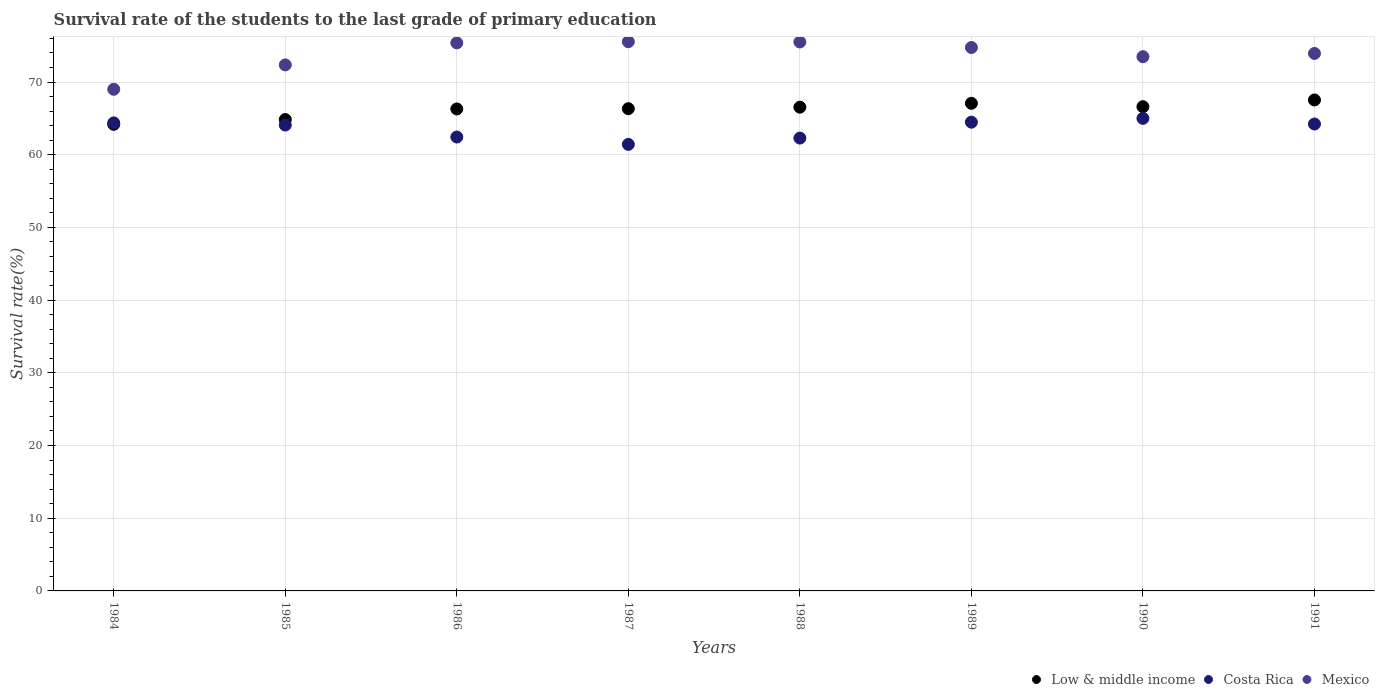How many different coloured dotlines are there?
Make the answer very short. 3. Is the number of dotlines equal to the number of legend labels?
Your answer should be compact. Yes. What is the survival rate of the students in Low & middle income in 1990?
Your answer should be compact. 66.61. Across all years, what is the maximum survival rate of the students in Costa Rica?
Give a very brief answer. 65. Across all years, what is the minimum survival rate of the students in Costa Rica?
Provide a short and direct response. 61.42. What is the total survival rate of the students in Mexico in the graph?
Offer a very short reply. 589.96. What is the difference between the survival rate of the students in Mexico in 1986 and that in 1987?
Make the answer very short. -0.16. What is the difference between the survival rate of the students in Mexico in 1988 and the survival rate of the students in Costa Rica in 1986?
Provide a short and direct response. 13.07. What is the average survival rate of the students in Mexico per year?
Your answer should be very brief. 73.74. In the year 1989, what is the difference between the survival rate of the students in Mexico and survival rate of the students in Costa Rica?
Ensure brevity in your answer.  10.27. What is the ratio of the survival rate of the students in Costa Rica in 1987 to that in 1989?
Provide a short and direct response. 0.95. Is the difference between the survival rate of the students in Mexico in 1988 and 1989 greater than the difference between the survival rate of the students in Costa Rica in 1988 and 1989?
Your answer should be compact. Yes. What is the difference between the highest and the second highest survival rate of the students in Low & middle income?
Your answer should be compact. 0.46. What is the difference between the highest and the lowest survival rate of the students in Mexico?
Ensure brevity in your answer.  6.54. In how many years, is the survival rate of the students in Low & middle income greater than the average survival rate of the students in Low & middle income taken over all years?
Provide a succinct answer. 6. Is it the case that in every year, the sum of the survival rate of the students in Costa Rica and survival rate of the students in Mexico  is greater than the survival rate of the students in Low & middle income?
Your response must be concise. Yes. Is the survival rate of the students in Costa Rica strictly less than the survival rate of the students in Mexico over the years?
Offer a terse response. Yes. Does the graph contain grids?
Provide a short and direct response. Yes. How many legend labels are there?
Give a very brief answer. 3. What is the title of the graph?
Offer a terse response. Survival rate of the students to the last grade of primary education. Does "Croatia" appear as one of the legend labels in the graph?
Give a very brief answer. No. What is the label or title of the Y-axis?
Keep it short and to the point. Survival rate(%). What is the Survival rate(%) of Low & middle income in 1984?
Provide a succinct answer. 64.18. What is the Survival rate(%) of Costa Rica in 1984?
Your response must be concise. 64.38. What is the Survival rate(%) of Mexico in 1984?
Give a very brief answer. 69. What is the Survival rate(%) in Low & middle income in 1985?
Give a very brief answer. 64.84. What is the Survival rate(%) in Costa Rica in 1985?
Offer a terse response. 64.08. What is the Survival rate(%) of Mexico in 1985?
Provide a succinct answer. 72.36. What is the Survival rate(%) in Low & middle income in 1986?
Your response must be concise. 66.3. What is the Survival rate(%) of Costa Rica in 1986?
Provide a short and direct response. 62.43. What is the Survival rate(%) of Mexico in 1986?
Make the answer very short. 75.39. What is the Survival rate(%) of Low & middle income in 1987?
Make the answer very short. 66.33. What is the Survival rate(%) of Costa Rica in 1987?
Offer a terse response. 61.42. What is the Survival rate(%) of Mexico in 1987?
Offer a very short reply. 75.55. What is the Survival rate(%) of Low & middle income in 1988?
Your response must be concise. 66.54. What is the Survival rate(%) in Costa Rica in 1988?
Keep it short and to the point. 62.29. What is the Survival rate(%) of Mexico in 1988?
Offer a very short reply. 75.51. What is the Survival rate(%) of Low & middle income in 1989?
Offer a very short reply. 67.07. What is the Survival rate(%) of Costa Rica in 1989?
Give a very brief answer. 64.48. What is the Survival rate(%) in Mexico in 1989?
Ensure brevity in your answer.  74.74. What is the Survival rate(%) of Low & middle income in 1990?
Your answer should be compact. 66.61. What is the Survival rate(%) of Costa Rica in 1990?
Your answer should be very brief. 65. What is the Survival rate(%) in Mexico in 1990?
Keep it short and to the point. 73.48. What is the Survival rate(%) in Low & middle income in 1991?
Your response must be concise. 67.53. What is the Survival rate(%) in Costa Rica in 1991?
Your answer should be compact. 64.22. What is the Survival rate(%) of Mexico in 1991?
Your answer should be compact. 73.93. Across all years, what is the maximum Survival rate(%) of Low & middle income?
Keep it short and to the point. 67.53. Across all years, what is the maximum Survival rate(%) of Costa Rica?
Make the answer very short. 65. Across all years, what is the maximum Survival rate(%) in Mexico?
Give a very brief answer. 75.55. Across all years, what is the minimum Survival rate(%) in Low & middle income?
Ensure brevity in your answer.  64.18. Across all years, what is the minimum Survival rate(%) of Costa Rica?
Provide a short and direct response. 61.42. Across all years, what is the minimum Survival rate(%) in Mexico?
Your answer should be compact. 69. What is the total Survival rate(%) of Low & middle income in the graph?
Provide a short and direct response. 529.4. What is the total Survival rate(%) in Costa Rica in the graph?
Offer a terse response. 508.3. What is the total Survival rate(%) of Mexico in the graph?
Provide a short and direct response. 589.96. What is the difference between the Survival rate(%) in Low & middle income in 1984 and that in 1985?
Offer a terse response. -0.66. What is the difference between the Survival rate(%) in Costa Rica in 1984 and that in 1985?
Provide a succinct answer. 0.3. What is the difference between the Survival rate(%) of Mexico in 1984 and that in 1985?
Give a very brief answer. -3.35. What is the difference between the Survival rate(%) in Low & middle income in 1984 and that in 1986?
Make the answer very short. -2.11. What is the difference between the Survival rate(%) in Costa Rica in 1984 and that in 1986?
Your response must be concise. 1.94. What is the difference between the Survival rate(%) of Mexico in 1984 and that in 1986?
Offer a terse response. -6.38. What is the difference between the Survival rate(%) of Low & middle income in 1984 and that in 1987?
Your answer should be compact. -2.15. What is the difference between the Survival rate(%) in Costa Rica in 1984 and that in 1987?
Make the answer very short. 2.96. What is the difference between the Survival rate(%) of Mexico in 1984 and that in 1987?
Your response must be concise. -6.54. What is the difference between the Survival rate(%) of Low & middle income in 1984 and that in 1988?
Ensure brevity in your answer.  -2.36. What is the difference between the Survival rate(%) in Costa Rica in 1984 and that in 1988?
Provide a succinct answer. 2.09. What is the difference between the Survival rate(%) of Mexico in 1984 and that in 1988?
Keep it short and to the point. -6.51. What is the difference between the Survival rate(%) in Low & middle income in 1984 and that in 1989?
Make the answer very short. -2.89. What is the difference between the Survival rate(%) in Costa Rica in 1984 and that in 1989?
Give a very brief answer. -0.1. What is the difference between the Survival rate(%) in Mexico in 1984 and that in 1989?
Give a very brief answer. -5.74. What is the difference between the Survival rate(%) in Low & middle income in 1984 and that in 1990?
Make the answer very short. -2.42. What is the difference between the Survival rate(%) of Costa Rica in 1984 and that in 1990?
Offer a very short reply. -0.62. What is the difference between the Survival rate(%) of Mexico in 1984 and that in 1990?
Ensure brevity in your answer.  -4.48. What is the difference between the Survival rate(%) of Low & middle income in 1984 and that in 1991?
Keep it short and to the point. -3.35. What is the difference between the Survival rate(%) of Costa Rica in 1984 and that in 1991?
Provide a succinct answer. 0.16. What is the difference between the Survival rate(%) in Mexico in 1984 and that in 1991?
Offer a very short reply. -4.93. What is the difference between the Survival rate(%) of Low & middle income in 1985 and that in 1986?
Your answer should be very brief. -1.45. What is the difference between the Survival rate(%) in Costa Rica in 1985 and that in 1986?
Provide a short and direct response. 1.64. What is the difference between the Survival rate(%) in Mexico in 1985 and that in 1986?
Ensure brevity in your answer.  -3.03. What is the difference between the Survival rate(%) in Low & middle income in 1985 and that in 1987?
Make the answer very short. -1.49. What is the difference between the Survival rate(%) in Costa Rica in 1985 and that in 1987?
Your response must be concise. 2.66. What is the difference between the Survival rate(%) in Mexico in 1985 and that in 1987?
Keep it short and to the point. -3.19. What is the difference between the Survival rate(%) of Low & middle income in 1985 and that in 1988?
Provide a short and direct response. -1.7. What is the difference between the Survival rate(%) in Costa Rica in 1985 and that in 1988?
Your answer should be very brief. 1.79. What is the difference between the Survival rate(%) in Mexico in 1985 and that in 1988?
Provide a short and direct response. -3.15. What is the difference between the Survival rate(%) in Low & middle income in 1985 and that in 1989?
Offer a terse response. -2.23. What is the difference between the Survival rate(%) in Costa Rica in 1985 and that in 1989?
Provide a short and direct response. -0.4. What is the difference between the Survival rate(%) in Mexico in 1985 and that in 1989?
Keep it short and to the point. -2.39. What is the difference between the Survival rate(%) of Low & middle income in 1985 and that in 1990?
Your response must be concise. -1.77. What is the difference between the Survival rate(%) of Costa Rica in 1985 and that in 1990?
Give a very brief answer. -0.92. What is the difference between the Survival rate(%) in Mexico in 1985 and that in 1990?
Make the answer very short. -1.13. What is the difference between the Survival rate(%) in Low & middle income in 1985 and that in 1991?
Offer a very short reply. -2.69. What is the difference between the Survival rate(%) of Costa Rica in 1985 and that in 1991?
Ensure brevity in your answer.  -0.14. What is the difference between the Survival rate(%) of Mexico in 1985 and that in 1991?
Give a very brief answer. -1.57. What is the difference between the Survival rate(%) in Low & middle income in 1986 and that in 1987?
Make the answer very short. -0.04. What is the difference between the Survival rate(%) in Costa Rica in 1986 and that in 1987?
Your answer should be very brief. 1.01. What is the difference between the Survival rate(%) of Mexico in 1986 and that in 1987?
Provide a succinct answer. -0.16. What is the difference between the Survival rate(%) in Low & middle income in 1986 and that in 1988?
Offer a very short reply. -0.24. What is the difference between the Survival rate(%) in Costa Rica in 1986 and that in 1988?
Offer a very short reply. 0.14. What is the difference between the Survival rate(%) of Mexico in 1986 and that in 1988?
Provide a short and direct response. -0.12. What is the difference between the Survival rate(%) of Low & middle income in 1986 and that in 1989?
Provide a short and direct response. -0.77. What is the difference between the Survival rate(%) of Costa Rica in 1986 and that in 1989?
Offer a very short reply. -2.04. What is the difference between the Survival rate(%) in Mexico in 1986 and that in 1989?
Provide a succinct answer. 0.64. What is the difference between the Survival rate(%) in Low & middle income in 1986 and that in 1990?
Offer a very short reply. -0.31. What is the difference between the Survival rate(%) of Costa Rica in 1986 and that in 1990?
Provide a succinct answer. -2.57. What is the difference between the Survival rate(%) in Mexico in 1986 and that in 1990?
Make the answer very short. 1.9. What is the difference between the Survival rate(%) of Low & middle income in 1986 and that in 1991?
Ensure brevity in your answer.  -1.24. What is the difference between the Survival rate(%) in Costa Rica in 1986 and that in 1991?
Ensure brevity in your answer.  -1.79. What is the difference between the Survival rate(%) of Mexico in 1986 and that in 1991?
Your answer should be compact. 1.45. What is the difference between the Survival rate(%) of Low & middle income in 1987 and that in 1988?
Ensure brevity in your answer.  -0.21. What is the difference between the Survival rate(%) in Costa Rica in 1987 and that in 1988?
Offer a terse response. -0.87. What is the difference between the Survival rate(%) of Mexico in 1987 and that in 1988?
Give a very brief answer. 0.04. What is the difference between the Survival rate(%) of Low & middle income in 1987 and that in 1989?
Your answer should be very brief. -0.74. What is the difference between the Survival rate(%) in Costa Rica in 1987 and that in 1989?
Provide a short and direct response. -3.05. What is the difference between the Survival rate(%) of Mexico in 1987 and that in 1989?
Ensure brevity in your answer.  0.8. What is the difference between the Survival rate(%) in Low & middle income in 1987 and that in 1990?
Provide a short and direct response. -0.27. What is the difference between the Survival rate(%) of Costa Rica in 1987 and that in 1990?
Keep it short and to the point. -3.58. What is the difference between the Survival rate(%) in Mexico in 1987 and that in 1990?
Your response must be concise. 2.06. What is the difference between the Survival rate(%) of Low & middle income in 1987 and that in 1991?
Offer a very short reply. -1.2. What is the difference between the Survival rate(%) in Costa Rica in 1987 and that in 1991?
Provide a succinct answer. -2.8. What is the difference between the Survival rate(%) of Mexico in 1987 and that in 1991?
Your answer should be very brief. 1.61. What is the difference between the Survival rate(%) in Low & middle income in 1988 and that in 1989?
Offer a terse response. -0.53. What is the difference between the Survival rate(%) in Costa Rica in 1988 and that in 1989?
Your response must be concise. -2.19. What is the difference between the Survival rate(%) in Mexico in 1988 and that in 1989?
Your response must be concise. 0.76. What is the difference between the Survival rate(%) of Low & middle income in 1988 and that in 1990?
Offer a terse response. -0.07. What is the difference between the Survival rate(%) of Costa Rica in 1988 and that in 1990?
Your response must be concise. -2.71. What is the difference between the Survival rate(%) of Mexico in 1988 and that in 1990?
Keep it short and to the point. 2.03. What is the difference between the Survival rate(%) of Low & middle income in 1988 and that in 1991?
Provide a short and direct response. -1. What is the difference between the Survival rate(%) of Costa Rica in 1988 and that in 1991?
Your response must be concise. -1.93. What is the difference between the Survival rate(%) in Mexico in 1988 and that in 1991?
Your answer should be very brief. 1.58. What is the difference between the Survival rate(%) in Low & middle income in 1989 and that in 1990?
Give a very brief answer. 0.46. What is the difference between the Survival rate(%) of Costa Rica in 1989 and that in 1990?
Keep it short and to the point. -0.53. What is the difference between the Survival rate(%) in Mexico in 1989 and that in 1990?
Offer a terse response. 1.26. What is the difference between the Survival rate(%) of Low & middle income in 1989 and that in 1991?
Your answer should be compact. -0.46. What is the difference between the Survival rate(%) of Costa Rica in 1989 and that in 1991?
Your response must be concise. 0.25. What is the difference between the Survival rate(%) in Mexico in 1989 and that in 1991?
Offer a terse response. 0.81. What is the difference between the Survival rate(%) in Low & middle income in 1990 and that in 1991?
Provide a succinct answer. -0.93. What is the difference between the Survival rate(%) in Costa Rica in 1990 and that in 1991?
Offer a very short reply. 0.78. What is the difference between the Survival rate(%) of Mexico in 1990 and that in 1991?
Your answer should be compact. -0.45. What is the difference between the Survival rate(%) in Low & middle income in 1984 and the Survival rate(%) in Costa Rica in 1985?
Ensure brevity in your answer.  0.1. What is the difference between the Survival rate(%) in Low & middle income in 1984 and the Survival rate(%) in Mexico in 1985?
Your answer should be very brief. -8.17. What is the difference between the Survival rate(%) in Costa Rica in 1984 and the Survival rate(%) in Mexico in 1985?
Ensure brevity in your answer.  -7.98. What is the difference between the Survival rate(%) in Low & middle income in 1984 and the Survival rate(%) in Costa Rica in 1986?
Ensure brevity in your answer.  1.75. What is the difference between the Survival rate(%) in Low & middle income in 1984 and the Survival rate(%) in Mexico in 1986?
Offer a terse response. -11.2. What is the difference between the Survival rate(%) of Costa Rica in 1984 and the Survival rate(%) of Mexico in 1986?
Provide a short and direct response. -11.01. What is the difference between the Survival rate(%) in Low & middle income in 1984 and the Survival rate(%) in Costa Rica in 1987?
Offer a terse response. 2.76. What is the difference between the Survival rate(%) in Low & middle income in 1984 and the Survival rate(%) in Mexico in 1987?
Offer a terse response. -11.36. What is the difference between the Survival rate(%) in Costa Rica in 1984 and the Survival rate(%) in Mexico in 1987?
Make the answer very short. -11.17. What is the difference between the Survival rate(%) of Low & middle income in 1984 and the Survival rate(%) of Costa Rica in 1988?
Provide a short and direct response. 1.89. What is the difference between the Survival rate(%) in Low & middle income in 1984 and the Survival rate(%) in Mexico in 1988?
Offer a terse response. -11.33. What is the difference between the Survival rate(%) of Costa Rica in 1984 and the Survival rate(%) of Mexico in 1988?
Offer a very short reply. -11.13. What is the difference between the Survival rate(%) in Low & middle income in 1984 and the Survival rate(%) in Costa Rica in 1989?
Provide a succinct answer. -0.29. What is the difference between the Survival rate(%) in Low & middle income in 1984 and the Survival rate(%) in Mexico in 1989?
Provide a short and direct response. -10.56. What is the difference between the Survival rate(%) of Costa Rica in 1984 and the Survival rate(%) of Mexico in 1989?
Give a very brief answer. -10.37. What is the difference between the Survival rate(%) of Low & middle income in 1984 and the Survival rate(%) of Costa Rica in 1990?
Make the answer very short. -0.82. What is the difference between the Survival rate(%) in Low & middle income in 1984 and the Survival rate(%) in Mexico in 1990?
Make the answer very short. -9.3. What is the difference between the Survival rate(%) in Costa Rica in 1984 and the Survival rate(%) in Mexico in 1990?
Ensure brevity in your answer.  -9.11. What is the difference between the Survival rate(%) of Low & middle income in 1984 and the Survival rate(%) of Costa Rica in 1991?
Offer a terse response. -0.04. What is the difference between the Survival rate(%) of Low & middle income in 1984 and the Survival rate(%) of Mexico in 1991?
Provide a succinct answer. -9.75. What is the difference between the Survival rate(%) of Costa Rica in 1984 and the Survival rate(%) of Mexico in 1991?
Offer a terse response. -9.55. What is the difference between the Survival rate(%) of Low & middle income in 1985 and the Survival rate(%) of Costa Rica in 1986?
Offer a terse response. 2.41. What is the difference between the Survival rate(%) of Low & middle income in 1985 and the Survival rate(%) of Mexico in 1986?
Offer a very short reply. -10.54. What is the difference between the Survival rate(%) in Costa Rica in 1985 and the Survival rate(%) in Mexico in 1986?
Give a very brief answer. -11.31. What is the difference between the Survival rate(%) in Low & middle income in 1985 and the Survival rate(%) in Costa Rica in 1987?
Make the answer very short. 3.42. What is the difference between the Survival rate(%) in Low & middle income in 1985 and the Survival rate(%) in Mexico in 1987?
Your answer should be compact. -10.7. What is the difference between the Survival rate(%) of Costa Rica in 1985 and the Survival rate(%) of Mexico in 1987?
Offer a very short reply. -11.47. What is the difference between the Survival rate(%) in Low & middle income in 1985 and the Survival rate(%) in Costa Rica in 1988?
Offer a terse response. 2.55. What is the difference between the Survival rate(%) in Low & middle income in 1985 and the Survival rate(%) in Mexico in 1988?
Your response must be concise. -10.67. What is the difference between the Survival rate(%) of Costa Rica in 1985 and the Survival rate(%) of Mexico in 1988?
Your answer should be compact. -11.43. What is the difference between the Survival rate(%) of Low & middle income in 1985 and the Survival rate(%) of Costa Rica in 1989?
Provide a succinct answer. 0.36. What is the difference between the Survival rate(%) in Low & middle income in 1985 and the Survival rate(%) in Mexico in 1989?
Your answer should be compact. -9.9. What is the difference between the Survival rate(%) of Costa Rica in 1985 and the Survival rate(%) of Mexico in 1989?
Your response must be concise. -10.67. What is the difference between the Survival rate(%) of Low & middle income in 1985 and the Survival rate(%) of Costa Rica in 1990?
Your answer should be very brief. -0.16. What is the difference between the Survival rate(%) of Low & middle income in 1985 and the Survival rate(%) of Mexico in 1990?
Provide a succinct answer. -8.64. What is the difference between the Survival rate(%) in Costa Rica in 1985 and the Survival rate(%) in Mexico in 1990?
Your response must be concise. -9.4. What is the difference between the Survival rate(%) of Low & middle income in 1985 and the Survival rate(%) of Costa Rica in 1991?
Offer a very short reply. 0.62. What is the difference between the Survival rate(%) of Low & middle income in 1985 and the Survival rate(%) of Mexico in 1991?
Give a very brief answer. -9.09. What is the difference between the Survival rate(%) in Costa Rica in 1985 and the Survival rate(%) in Mexico in 1991?
Your answer should be compact. -9.85. What is the difference between the Survival rate(%) of Low & middle income in 1986 and the Survival rate(%) of Costa Rica in 1987?
Keep it short and to the point. 4.87. What is the difference between the Survival rate(%) of Low & middle income in 1986 and the Survival rate(%) of Mexico in 1987?
Your response must be concise. -9.25. What is the difference between the Survival rate(%) in Costa Rica in 1986 and the Survival rate(%) in Mexico in 1987?
Ensure brevity in your answer.  -13.11. What is the difference between the Survival rate(%) in Low & middle income in 1986 and the Survival rate(%) in Costa Rica in 1988?
Your answer should be very brief. 4. What is the difference between the Survival rate(%) in Low & middle income in 1986 and the Survival rate(%) in Mexico in 1988?
Offer a very short reply. -9.21. What is the difference between the Survival rate(%) in Costa Rica in 1986 and the Survival rate(%) in Mexico in 1988?
Offer a terse response. -13.07. What is the difference between the Survival rate(%) in Low & middle income in 1986 and the Survival rate(%) in Costa Rica in 1989?
Keep it short and to the point. 1.82. What is the difference between the Survival rate(%) in Low & middle income in 1986 and the Survival rate(%) in Mexico in 1989?
Your answer should be compact. -8.45. What is the difference between the Survival rate(%) in Costa Rica in 1986 and the Survival rate(%) in Mexico in 1989?
Ensure brevity in your answer.  -12.31. What is the difference between the Survival rate(%) of Low & middle income in 1986 and the Survival rate(%) of Costa Rica in 1990?
Make the answer very short. 1.29. What is the difference between the Survival rate(%) of Low & middle income in 1986 and the Survival rate(%) of Mexico in 1990?
Offer a terse response. -7.19. What is the difference between the Survival rate(%) in Costa Rica in 1986 and the Survival rate(%) in Mexico in 1990?
Give a very brief answer. -11.05. What is the difference between the Survival rate(%) in Low & middle income in 1986 and the Survival rate(%) in Costa Rica in 1991?
Provide a short and direct response. 2.07. What is the difference between the Survival rate(%) in Low & middle income in 1986 and the Survival rate(%) in Mexico in 1991?
Offer a terse response. -7.64. What is the difference between the Survival rate(%) of Costa Rica in 1986 and the Survival rate(%) of Mexico in 1991?
Offer a terse response. -11.5. What is the difference between the Survival rate(%) of Low & middle income in 1987 and the Survival rate(%) of Costa Rica in 1988?
Your answer should be very brief. 4.04. What is the difference between the Survival rate(%) in Low & middle income in 1987 and the Survival rate(%) in Mexico in 1988?
Keep it short and to the point. -9.18. What is the difference between the Survival rate(%) in Costa Rica in 1987 and the Survival rate(%) in Mexico in 1988?
Provide a short and direct response. -14.09. What is the difference between the Survival rate(%) in Low & middle income in 1987 and the Survival rate(%) in Costa Rica in 1989?
Ensure brevity in your answer.  1.86. What is the difference between the Survival rate(%) in Low & middle income in 1987 and the Survival rate(%) in Mexico in 1989?
Your answer should be compact. -8.41. What is the difference between the Survival rate(%) in Costa Rica in 1987 and the Survival rate(%) in Mexico in 1989?
Ensure brevity in your answer.  -13.32. What is the difference between the Survival rate(%) in Low & middle income in 1987 and the Survival rate(%) in Costa Rica in 1990?
Keep it short and to the point. 1.33. What is the difference between the Survival rate(%) in Low & middle income in 1987 and the Survival rate(%) in Mexico in 1990?
Offer a terse response. -7.15. What is the difference between the Survival rate(%) of Costa Rica in 1987 and the Survival rate(%) of Mexico in 1990?
Provide a short and direct response. -12.06. What is the difference between the Survival rate(%) of Low & middle income in 1987 and the Survival rate(%) of Costa Rica in 1991?
Offer a terse response. 2.11. What is the difference between the Survival rate(%) in Low & middle income in 1987 and the Survival rate(%) in Mexico in 1991?
Offer a terse response. -7.6. What is the difference between the Survival rate(%) of Costa Rica in 1987 and the Survival rate(%) of Mexico in 1991?
Offer a terse response. -12.51. What is the difference between the Survival rate(%) of Low & middle income in 1988 and the Survival rate(%) of Costa Rica in 1989?
Your response must be concise. 2.06. What is the difference between the Survival rate(%) in Low & middle income in 1988 and the Survival rate(%) in Mexico in 1989?
Make the answer very short. -8.21. What is the difference between the Survival rate(%) in Costa Rica in 1988 and the Survival rate(%) in Mexico in 1989?
Provide a short and direct response. -12.45. What is the difference between the Survival rate(%) of Low & middle income in 1988 and the Survival rate(%) of Costa Rica in 1990?
Provide a succinct answer. 1.54. What is the difference between the Survival rate(%) of Low & middle income in 1988 and the Survival rate(%) of Mexico in 1990?
Keep it short and to the point. -6.95. What is the difference between the Survival rate(%) of Costa Rica in 1988 and the Survival rate(%) of Mexico in 1990?
Provide a short and direct response. -11.19. What is the difference between the Survival rate(%) in Low & middle income in 1988 and the Survival rate(%) in Costa Rica in 1991?
Make the answer very short. 2.32. What is the difference between the Survival rate(%) of Low & middle income in 1988 and the Survival rate(%) of Mexico in 1991?
Offer a very short reply. -7.39. What is the difference between the Survival rate(%) of Costa Rica in 1988 and the Survival rate(%) of Mexico in 1991?
Your response must be concise. -11.64. What is the difference between the Survival rate(%) in Low & middle income in 1989 and the Survival rate(%) in Costa Rica in 1990?
Keep it short and to the point. 2.07. What is the difference between the Survival rate(%) of Low & middle income in 1989 and the Survival rate(%) of Mexico in 1990?
Ensure brevity in your answer.  -6.41. What is the difference between the Survival rate(%) of Costa Rica in 1989 and the Survival rate(%) of Mexico in 1990?
Make the answer very short. -9.01. What is the difference between the Survival rate(%) of Low & middle income in 1989 and the Survival rate(%) of Costa Rica in 1991?
Your answer should be compact. 2.85. What is the difference between the Survival rate(%) in Low & middle income in 1989 and the Survival rate(%) in Mexico in 1991?
Provide a short and direct response. -6.86. What is the difference between the Survival rate(%) in Costa Rica in 1989 and the Survival rate(%) in Mexico in 1991?
Provide a short and direct response. -9.46. What is the difference between the Survival rate(%) in Low & middle income in 1990 and the Survival rate(%) in Costa Rica in 1991?
Give a very brief answer. 2.38. What is the difference between the Survival rate(%) in Low & middle income in 1990 and the Survival rate(%) in Mexico in 1991?
Your answer should be compact. -7.33. What is the difference between the Survival rate(%) of Costa Rica in 1990 and the Survival rate(%) of Mexico in 1991?
Your answer should be compact. -8.93. What is the average Survival rate(%) in Low & middle income per year?
Provide a short and direct response. 66.17. What is the average Survival rate(%) of Costa Rica per year?
Your answer should be compact. 63.54. What is the average Survival rate(%) of Mexico per year?
Your answer should be very brief. 73.74. In the year 1984, what is the difference between the Survival rate(%) of Low & middle income and Survival rate(%) of Costa Rica?
Offer a very short reply. -0.2. In the year 1984, what is the difference between the Survival rate(%) in Low & middle income and Survival rate(%) in Mexico?
Provide a succinct answer. -4.82. In the year 1984, what is the difference between the Survival rate(%) of Costa Rica and Survival rate(%) of Mexico?
Your answer should be compact. -4.62. In the year 1985, what is the difference between the Survival rate(%) in Low & middle income and Survival rate(%) in Costa Rica?
Ensure brevity in your answer.  0.76. In the year 1985, what is the difference between the Survival rate(%) in Low & middle income and Survival rate(%) in Mexico?
Keep it short and to the point. -7.52. In the year 1985, what is the difference between the Survival rate(%) in Costa Rica and Survival rate(%) in Mexico?
Provide a short and direct response. -8.28. In the year 1986, what is the difference between the Survival rate(%) of Low & middle income and Survival rate(%) of Costa Rica?
Ensure brevity in your answer.  3.86. In the year 1986, what is the difference between the Survival rate(%) in Low & middle income and Survival rate(%) in Mexico?
Give a very brief answer. -9.09. In the year 1986, what is the difference between the Survival rate(%) in Costa Rica and Survival rate(%) in Mexico?
Your response must be concise. -12.95. In the year 1987, what is the difference between the Survival rate(%) in Low & middle income and Survival rate(%) in Costa Rica?
Provide a short and direct response. 4.91. In the year 1987, what is the difference between the Survival rate(%) in Low & middle income and Survival rate(%) in Mexico?
Provide a short and direct response. -9.21. In the year 1987, what is the difference between the Survival rate(%) of Costa Rica and Survival rate(%) of Mexico?
Offer a terse response. -14.12. In the year 1988, what is the difference between the Survival rate(%) in Low & middle income and Survival rate(%) in Costa Rica?
Keep it short and to the point. 4.25. In the year 1988, what is the difference between the Survival rate(%) of Low & middle income and Survival rate(%) of Mexico?
Keep it short and to the point. -8.97. In the year 1988, what is the difference between the Survival rate(%) in Costa Rica and Survival rate(%) in Mexico?
Your response must be concise. -13.22. In the year 1989, what is the difference between the Survival rate(%) of Low & middle income and Survival rate(%) of Costa Rica?
Provide a short and direct response. 2.59. In the year 1989, what is the difference between the Survival rate(%) in Low & middle income and Survival rate(%) in Mexico?
Provide a succinct answer. -7.68. In the year 1989, what is the difference between the Survival rate(%) in Costa Rica and Survival rate(%) in Mexico?
Make the answer very short. -10.27. In the year 1990, what is the difference between the Survival rate(%) of Low & middle income and Survival rate(%) of Costa Rica?
Ensure brevity in your answer.  1.6. In the year 1990, what is the difference between the Survival rate(%) in Low & middle income and Survival rate(%) in Mexico?
Offer a very short reply. -6.88. In the year 1990, what is the difference between the Survival rate(%) of Costa Rica and Survival rate(%) of Mexico?
Provide a short and direct response. -8.48. In the year 1991, what is the difference between the Survival rate(%) in Low & middle income and Survival rate(%) in Costa Rica?
Your answer should be very brief. 3.31. In the year 1991, what is the difference between the Survival rate(%) in Low & middle income and Survival rate(%) in Mexico?
Ensure brevity in your answer.  -6.4. In the year 1991, what is the difference between the Survival rate(%) in Costa Rica and Survival rate(%) in Mexico?
Keep it short and to the point. -9.71. What is the ratio of the Survival rate(%) in Mexico in 1984 to that in 1985?
Ensure brevity in your answer.  0.95. What is the ratio of the Survival rate(%) of Low & middle income in 1984 to that in 1986?
Offer a very short reply. 0.97. What is the ratio of the Survival rate(%) of Costa Rica in 1984 to that in 1986?
Provide a succinct answer. 1.03. What is the ratio of the Survival rate(%) of Mexico in 1984 to that in 1986?
Your answer should be compact. 0.92. What is the ratio of the Survival rate(%) in Low & middle income in 1984 to that in 1987?
Make the answer very short. 0.97. What is the ratio of the Survival rate(%) in Costa Rica in 1984 to that in 1987?
Your answer should be very brief. 1.05. What is the ratio of the Survival rate(%) in Mexico in 1984 to that in 1987?
Provide a succinct answer. 0.91. What is the ratio of the Survival rate(%) in Low & middle income in 1984 to that in 1988?
Offer a terse response. 0.96. What is the ratio of the Survival rate(%) in Costa Rica in 1984 to that in 1988?
Keep it short and to the point. 1.03. What is the ratio of the Survival rate(%) in Mexico in 1984 to that in 1988?
Give a very brief answer. 0.91. What is the ratio of the Survival rate(%) in Costa Rica in 1984 to that in 1989?
Give a very brief answer. 1. What is the ratio of the Survival rate(%) of Mexico in 1984 to that in 1989?
Make the answer very short. 0.92. What is the ratio of the Survival rate(%) in Low & middle income in 1984 to that in 1990?
Your answer should be compact. 0.96. What is the ratio of the Survival rate(%) of Costa Rica in 1984 to that in 1990?
Make the answer very short. 0.99. What is the ratio of the Survival rate(%) of Mexico in 1984 to that in 1990?
Your answer should be compact. 0.94. What is the ratio of the Survival rate(%) in Low & middle income in 1984 to that in 1991?
Provide a succinct answer. 0.95. What is the ratio of the Survival rate(%) in Costa Rica in 1984 to that in 1991?
Provide a succinct answer. 1. What is the ratio of the Survival rate(%) in Mexico in 1984 to that in 1991?
Your answer should be very brief. 0.93. What is the ratio of the Survival rate(%) of Low & middle income in 1985 to that in 1986?
Provide a succinct answer. 0.98. What is the ratio of the Survival rate(%) of Costa Rica in 1985 to that in 1986?
Offer a terse response. 1.03. What is the ratio of the Survival rate(%) in Mexico in 1985 to that in 1986?
Offer a terse response. 0.96. What is the ratio of the Survival rate(%) in Low & middle income in 1985 to that in 1987?
Ensure brevity in your answer.  0.98. What is the ratio of the Survival rate(%) of Costa Rica in 1985 to that in 1987?
Your answer should be very brief. 1.04. What is the ratio of the Survival rate(%) of Mexico in 1985 to that in 1987?
Your answer should be compact. 0.96. What is the ratio of the Survival rate(%) of Low & middle income in 1985 to that in 1988?
Your answer should be very brief. 0.97. What is the ratio of the Survival rate(%) in Costa Rica in 1985 to that in 1988?
Your answer should be very brief. 1.03. What is the ratio of the Survival rate(%) in Low & middle income in 1985 to that in 1989?
Give a very brief answer. 0.97. What is the ratio of the Survival rate(%) in Mexico in 1985 to that in 1989?
Provide a succinct answer. 0.97. What is the ratio of the Survival rate(%) of Low & middle income in 1985 to that in 1990?
Offer a very short reply. 0.97. What is the ratio of the Survival rate(%) of Costa Rica in 1985 to that in 1990?
Offer a terse response. 0.99. What is the ratio of the Survival rate(%) of Mexico in 1985 to that in 1990?
Your response must be concise. 0.98. What is the ratio of the Survival rate(%) of Low & middle income in 1985 to that in 1991?
Your answer should be compact. 0.96. What is the ratio of the Survival rate(%) in Costa Rica in 1985 to that in 1991?
Offer a terse response. 1. What is the ratio of the Survival rate(%) in Mexico in 1985 to that in 1991?
Your response must be concise. 0.98. What is the ratio of the Survival rate(%) in Low & middle income in 1986 to that in 1987?
Offer a terse response. 1. What is the ratio of the Survival rate(%) in Costa Rica in 1986 to that in 1987?
Offer a very short reply. 1.02. What is the ratio of the Survival rate(%) of Costa Rica in 1986 to that in 1988?
Offer a very short reply. 1. What is the ratio of the Survival rate(%) in Mexico in 1986 to that in 1988?
Ensure brevity in your answer.  1. What is the ratio of the Survival rate(%) in Costa Rica in 1986 to that in 1989?
Provide a succinct answer. 0.97. What is the ratio of the Survival rate(%) in Mexico in 1986 to that in 1989?
Give a very brief answer. 1.01. What is the ratio of the Survival rate(%) of Costa Rica in 1986 to that in 1990?
Your answer should be compact. 0.96. What is the ratio of the Survival rate(%) in Mexico in 1986 to that in 1990?
Offer a very short reply. 1.03. What is the ratio of the Survival rate(%) of Low & middle income in 1986 to that in 1991?
Make the answer very short. 0.98. What is the ratio of the Survival rate(%) in Costa Rica in 1986 to that in 1991?
Give a very brief answer. 0.97. What is the ratio of the Survival rate(%) in Mexico in 1986 to that in 1991?
Make the answer very short. 1.02. What is the ratio of the Survival rate(%) in Low & middle income in 1987 to that in 1988?
Provide a short and direct response. 1. What is the ratio of the Survival rate(%) in Costa Rica in 1987 to that in 1988?
Offer a terse response. 0.99. What is the ratio of the Survival rate(%) of Mexico in 1987 to that in 1988?
Your answer should be very brief. 1. What is the ratio of the Survival rate(%) in Costa Rica in 1987 to that in 1989?
Your response must be concise. 0.95. What is the ratio of the Survival rate(%) in Mexico in 1987 to that in 1989?
Your response must be concise. 1.01. What is the ratio of the Survival rate(%) of Costa Rica in 1987 to that in 1990?
Give a very brief answer. 0.94. What is the ratio of the Survival rate(%) of Mexico in 1987 to that in 1990?
Your response must be concise. 1.03. What is the ratio of the Survival rate(%) of Low & middle income in 1987 to that in 1991?
Your response must be concise. 0.98. What is the ratio of the Survival rate(%) of Costa Rica in 1987 to that in 1991?
Offer a terse response. 0.96. What is the ratio of the Survival rate(%) of Mexico in 1987 to that in 1991?
Offer a terse response. 1.02. What is the ratio of the Survival rate(%) in Costa Rica in 1988 to that in 1989?
Offer a terse response. 0.97. What is the ratio of the Survival rate(%) of Mexico in 1988 to that in 1989?
Your answer should be very brief. 1.01. What is the ratio of the Survival rate(%) in Costa Rica in 1988 to that in 1990?
Keep it short and to the point. 0.96. What is the ratio of the Survival rate(%) of Mexico in 1988 to that in 1990?
Ensure brevity in your answer.  1.03. What is the ratio of the Survival rate(%) in Costa Rica in 1988 to that in 1991?
Your answer should be very brief. 0.97. What is the ratio of the Survival rate(%) of Mexico in 1988 to that in 1991?
Your response must be concise. 1.02. What is the ratio of the Survival rate(%) of Costa Rica in 1989 to that in 1990?
Provide a succinct answer. 0.99. What is the ratio of the Survival rate(%) of Mexico in 1989 to that in 1990?
Make the answer very short. 1.02. What is the ratio of the Survival rate(%) of Low & middle income in 1989 to that in 1991?
Your answer should be very brief. 0.99. What is the ratio of the Survival rate(%) of Costa Rica in 1989 to that in 1991?
Offer a terse response. 1. What is the ratio of the Survival rate(%) in Low & middle income in 1990 to that in 1991?
Your answer should be very brief. 0.99. What is the ratio of the Survival rate(%) of Costa Rica in 1990 to that in 1991?
Offer a very short reply. 1.01. What is the difference between the highest and the second highest Survival rate(%) in Low & middle income?
Your answer should be compact. 0.46. What is the difference between the highest and the second highest Survival rate(%) of Costa Rica?
Ensure brevity in your answer.  0.53. What is the difference between the highest and the second highest Survival rate(%) of Mexico?
Offer a terse response. 0.04. What is the difference between the highest and the lowest Survival rate(%) in Low & middle income?
Provide a short and direct response. 3.35. What is the difference between the highest and the lowest Survival rate(%) in Costa Rica?
Give a very brief answer. 3.58. What is the difference between the highest and the lowest Survival rate(%) of Mexico?
Your response must be concise. 6.54. 